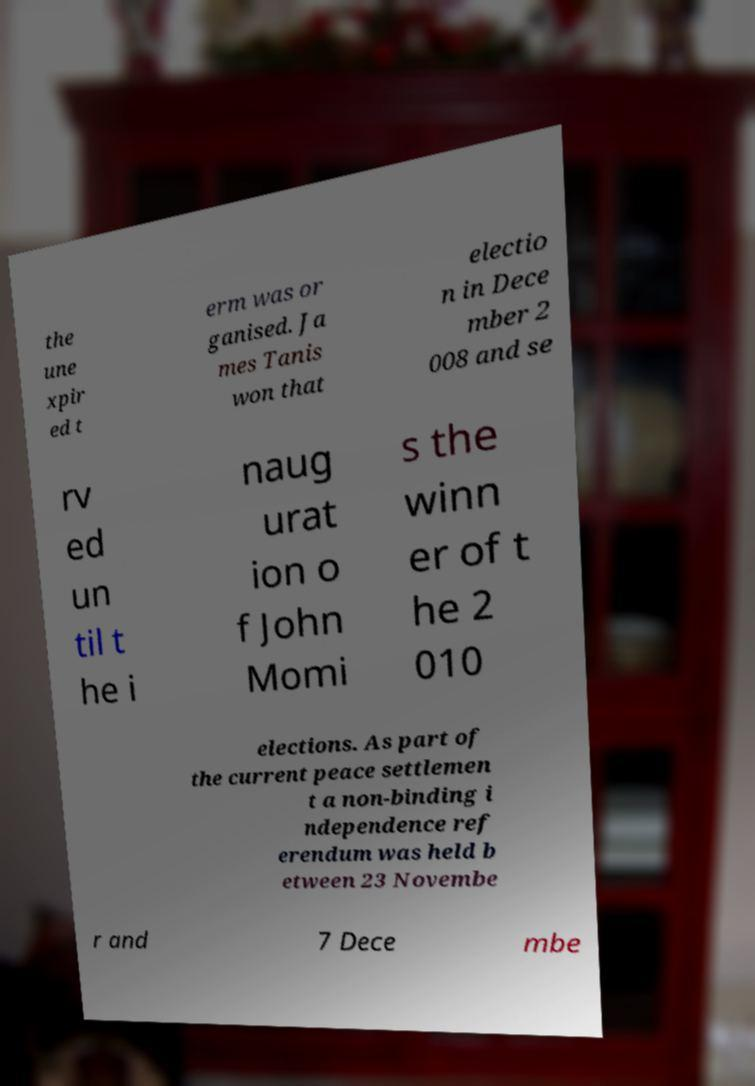For documentation purposes, I need the text within this image transcribed. Could you provide that? the une xpir ed t erm was or ganised. Ja mes Tanis won that electio n in Dece mber 2 008 and se rv ed un til t he i naug urat ion o f John Momi s the winn er of t he 2 010 elections. As part of the current peace settlemen t a non-binding i ndependence ref erendum was held b etween 23 Novembe r and 7 Dece mbe 